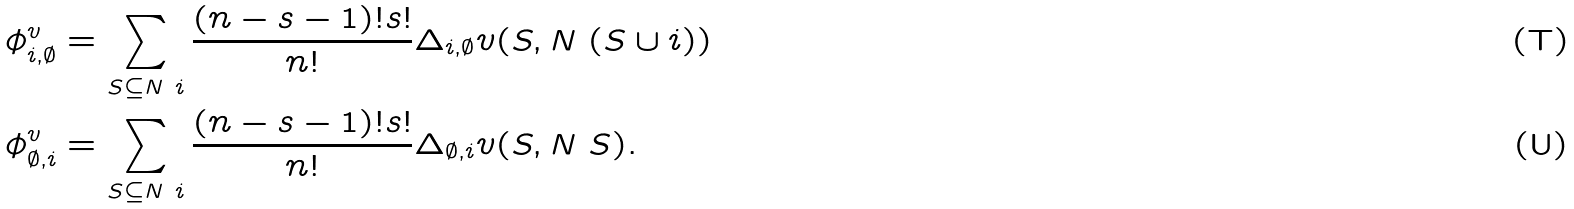Convert formula to latex. <formula><loc_0><loc_0><loc_500><loc_500>\phi ^ { v } _ { i , \emptyset } & = \sum _ { S \subseteq N \ i } \frac { ( n - s - 1 ) ! s ! } { n ! } \Delta _ { i , \emptyset } v ( S , N \ ( S \cup i ) ) \\ \phi ^ { v } _ { \emptyset , i } & = \sum _ { S \subseteq N \ i } \frac { ( n - s - 1 ) ! s ! } { n ! } \Delta _ { \emptyset , i } v ( S , N \ S ) .</formula> 